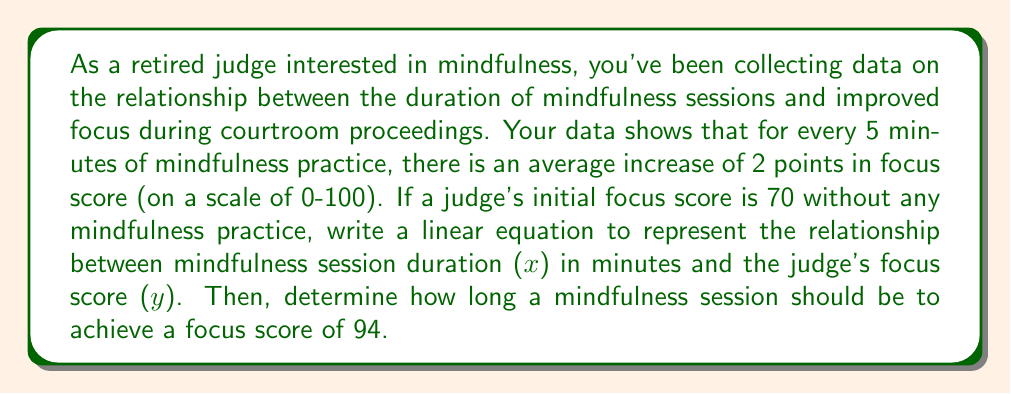Teach me how to tackle this problem. Let's approach this step-by-step:

1) First, we need to identify the components of a linear equation: $y = mx + b$
   Where:
   $y$ is the focus score
   $x$ is the duration of the mindfulness session in minutes
   $m$ is the slope (rate of change)
   $b$ is the y-intercept (initial focus score)

2) We're given that:
   - For every 5 minutes of practice, there's an increase of 2 points in focus score
   - The initial focus score (without practice) is 70

3) Let's calculate the slope ($m$):
   $m = \frac{\text{change in y}}{\text{change in x}} = \frac{2}{5} = 0.4$

4) We know the y-intercept ($b$) is 70

5) Now we can write our linear equation:
   $y = 0.4x + 70$

6) To find how long a session should be for a focus score of 94:
   $94 = 0.4x + 70$
   $24 = 0.4x$
   $x = 24 \div 0.4 = 60$

Therefore, a 60-minute mindfulness session would be needed to achieve a focus score of 94.
Answer: Linear equation: $y = 0.4x + 70$
Mindfulness session duration for a focus score of 94: 60 minutes 